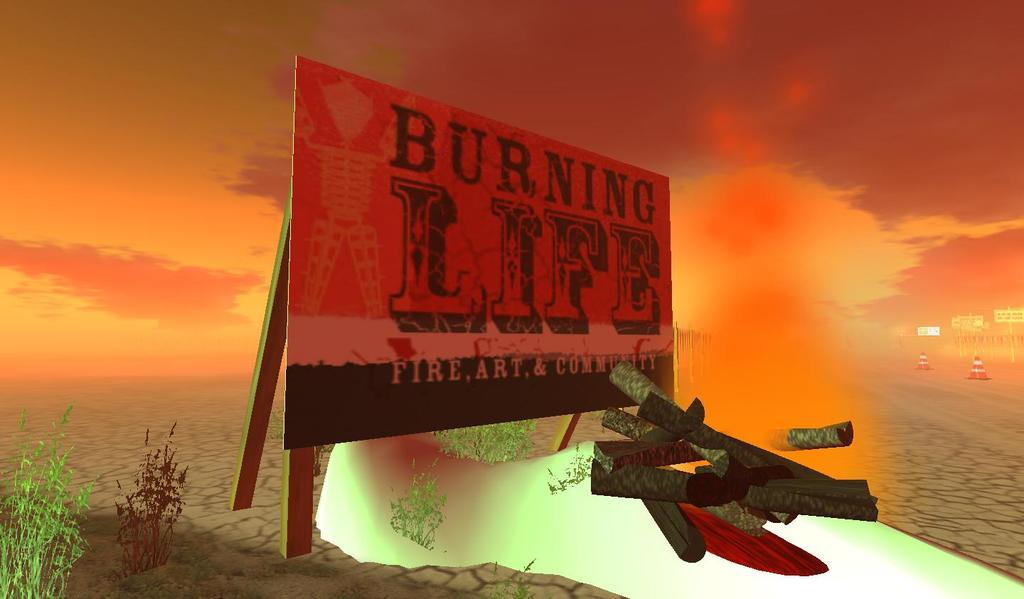<image>
Present a compact description of the photo's key features. A Burning Life poster stands on a dry desert with a fiery sunset in the background 